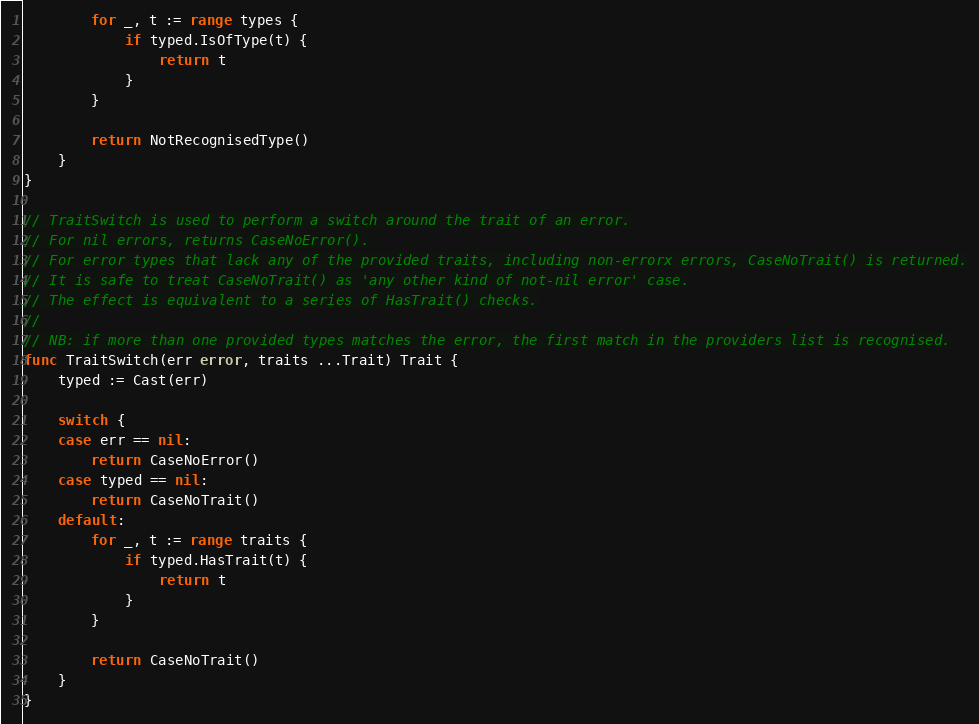<code> <loc_0><loc_0><loc_500><loc_500><_Go_>		for _, t := range types {
			if typed.IsOfType(t) {
				return t
			}
		}

		return NotRecognisedType()
	}
}

// TraitSwitch is used to perform a switch around the trait of an error.
// For nil errors, returns CaseNoError().
// For error types that lack any of the provided traits, including non-errorx errors, CaseNoTrait() is returned.
// It is safe to treat CaseNoTrait() as 'any other kind of not-nil error' case.
// The effect is equivalent to a series of HasTrait() checks.
//
// NB: if more than one provided types matches the error, the first match in the providers list is recognised.
func TraitSwitch(err error, traits ...Trait) Trait {
	typed := Cast(err)

	switch {
	case err == nil:
		return CaseNoError()
	case typed == nil:
		return CaseNoTrait()
	default:
		for _, t := range traits {
			if typed.HasTrait(t) {
				return t
			}
		}

		return CaseNoTrait()
	}
}
</code> 